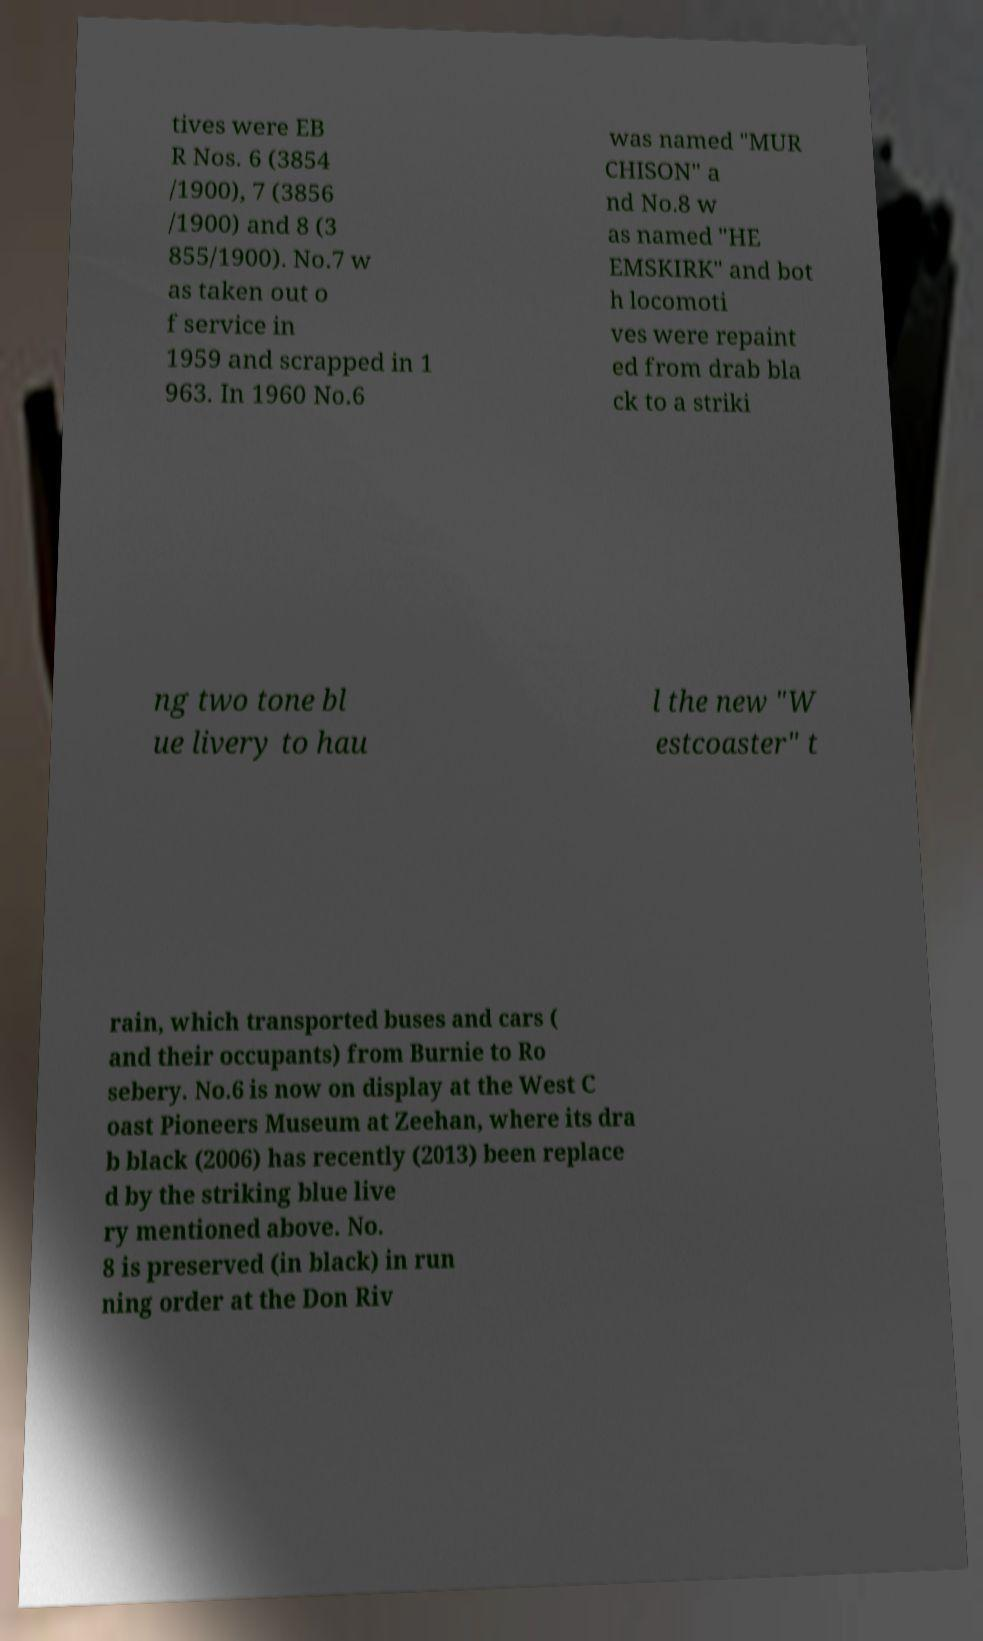Can you accurately transcribe the text from the provided image for me? tives were EB R Nos. 6 (3854 /1900), 7 (3856 /1900) and 8 (3 855/1900). No.7 w as taken out o f service in 1959 and scrapped in 1 963. In 1960 No.6 was named "MUR CHISON" a nd No.8 w as named "HE EMSKIRK" and bot h locomoti ves were repaint ed from drab bla ck to a striki ng two tone bl ue livery to hau l the new "W estcoaster" t rain, which transported buses and cars ( and their occupants) from Burnie to Ro sebery. No.6 is now on display at the West C oast Pioneers Museum at Zeehan, where its dra b black (2006) has recently (2013) been replace d by the striking blue live ry mentioned above. No. 8 is preserved (in black) in run ning order at the Don Riv 